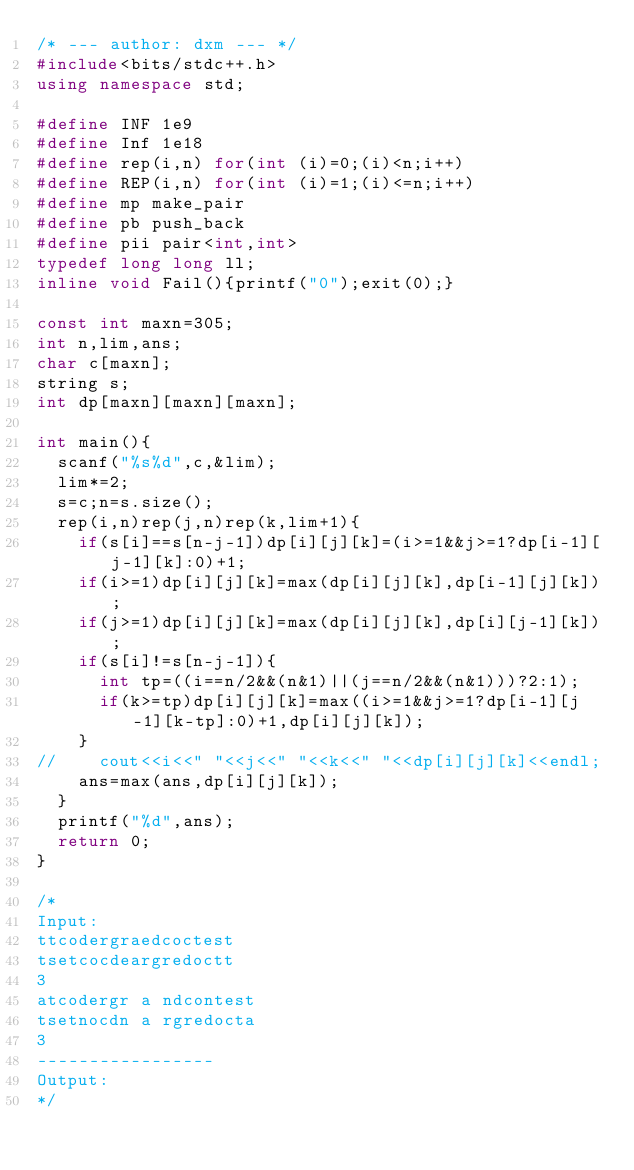<code> <loc_0><loc_0><loc_500><loc_500><_C++_>/* --- author: dxm --- */
#include<bits/stdc++.h>
using namespace std;

#define INF 1e9
#define Inf 1e18
#define rep(i,n) for(int (i)=0;(i)<n;i++)
#define REP(i,n) for(int (i)=1;(i)<=n;i++)
#define mp make_pair
#define pb push_back
#define pii pair<int,int>
typedef long long ll;
inline void Fail(){printf("0");exit(0);}

const int maxn=305;
int n,lim,ans;
char c[maxn];
string s;
int dp[maxn][maxn][maxn];

int main(){
	scanf("%s%d",c,&lim);
	lim*=2;
	s=c;n=s.size();
	rep(i,n)rep(j,n)rep(k,lim+1){
		if(s[i]==s[n-j-1])dp[i][j][k]=(i>=1&&j>=1?dp[i-1][j-1][k]:0)+1;
		if(i>=1)dp[i][j][k]=max(dp[i][j][k],dp[i-1][j][k]);
		if(j>=1)dp[i][j][k]=max(dp[i][j][k],dp[i][j-1][k]);
		if(s[i]!=s[n-j-1]){
			int tp=((i==n/2&&(n&1)||(j==n/2&&(n&1)))?2:1);
			if(k>=tp)dp[i][j][k]=max((i>=1&&j>=1?dp[i-1][j-1][k-tp]:0)+1,dp[i][j][k]);
		}
//		cout<<i<<" "<<j<<" "<<k<<" "<<dp[i][j][k]<<endl;
		ans=max(ans,dp[i][j][k]);
	}
	printf("%d",ans);
	return 0;
}

/*
Input:
ttcodergraedcoctest
tsetcocdeargredoctt
3
atcodergr a ndcontest
tsetnocdn a rgredocta
3
-----------------
Output:
*/</code> 